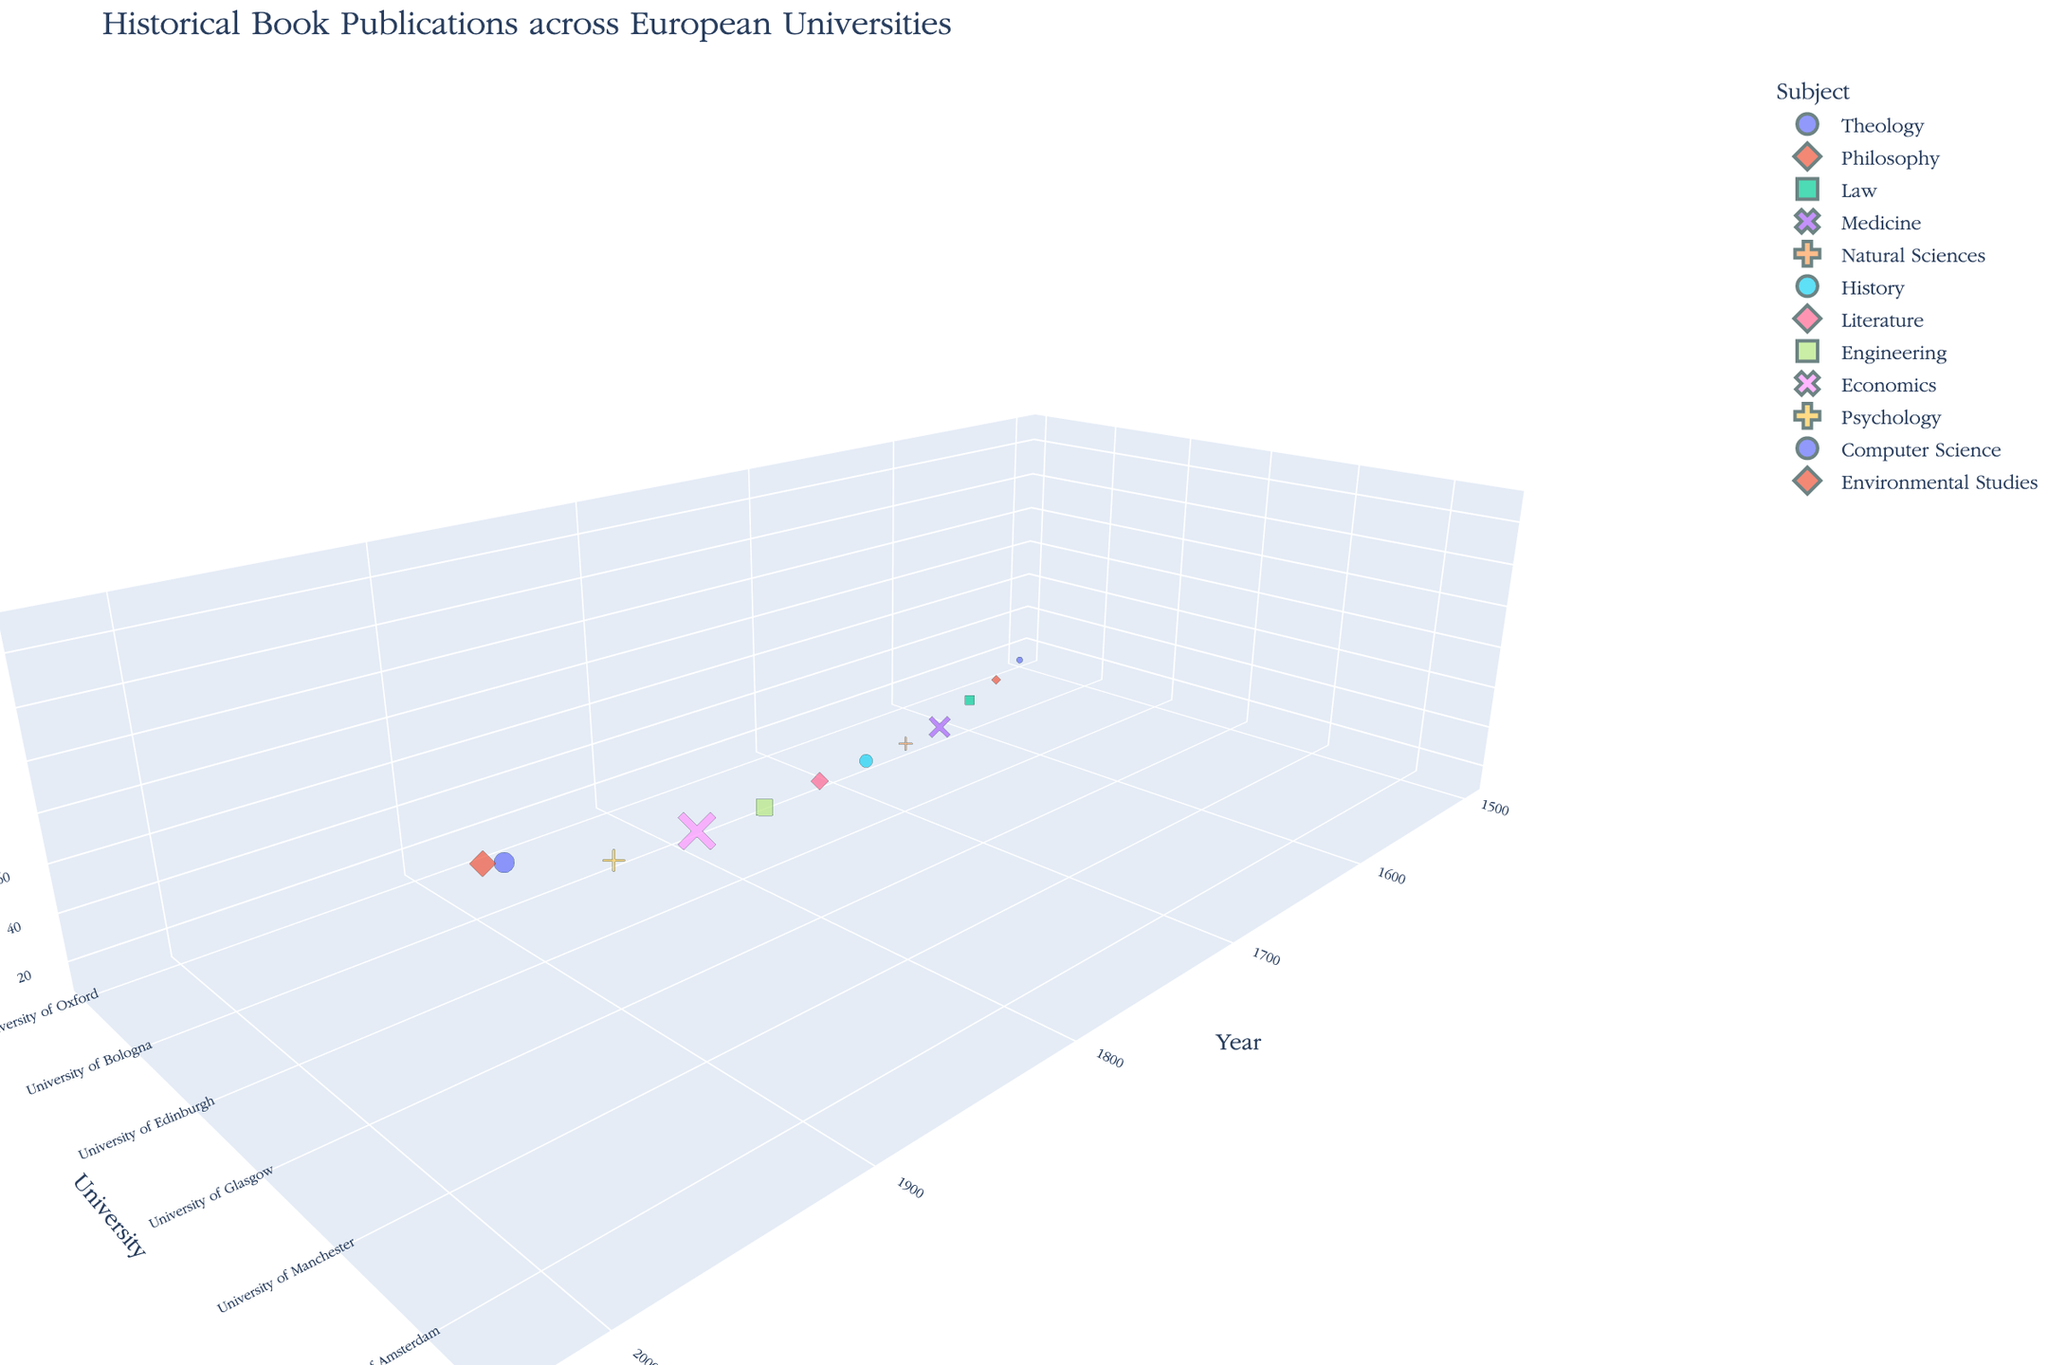How many subjects are represented in the plot? The plot shows each subject with a different color and symbol to distinguish them. There are 12 unique subjects indicated.
Answer: 12 Which university has the highest number of publications in the year 2000? By finding the data point corresponding to the year 2000 on the 'Year' axis and checking the 'Publications' value, you identify the 'University of Amsterdam' with 135 publications.
Answer: University of Amsterdam What is the overall trend in the number of historical book publications over time? Observing the z-axis (Publications) from the earliest to the latest years, you can see that the number of publications generally increases over time.
Answer: Increase over time Which university had the lowest number of publications, and in what year? By comparing all points and checking the lowest value on the 'Publications' axis, it is clear that 'University of Oxford' in the year 1500 had the lowest with 12 publications.
Answer: University of Oxford, 1500 Compare the number of publications between University of Paris in 1950 and University of Manchester in 1900. Which one has more publications and by how much? University of Paris in 1950 had 110 publications, and University of Manchester in 1900 had 95. The difference is 110 - 95 = 15.
Answer: University of Paris, 15 What is the average number of publications for the universities in the 20th century (1900 and 1950)? The 20th century years are 1900 and 1950. The publications are 95 (Manchester) and 110 (Paris). The average is (95 + 110) / 2 = 102.5.
Answer: 102.5 Identify the subject with the highest number of publications in the data. By checking the z-axis (Publications) for the maximum value, 'Environmental Studies' from Imperial College London in 2020 has the highest with 150 publications.
Answer: Environmental Studies How does the number of publications in Theology from University of Oxford in 1500 compare to the number in Computer Science from University of Amsterdam in 2000? University of Oxford in 1500 had 12 publications, and University of Amsterdam in 2000 had 135 publications. The difference is 135 - 12 = 123.
Answer: 123 What pattern can you observe regarding the universities and their subject specialties over time? By looking at the data points and their respective subjects over time, you can see that university subjects diversify, reflecting the academic and technical advancements of their respective periods.
Answer: Diversification over time Which two universities have a similar number of publications, and what is that number? Comparing the publication numbers, University College London in 1850 (80 publications) and University of Manchester in 1900 (95 publications) have relatively close numbers.
Answer: UCL and Manchester, about 80-95 publications 